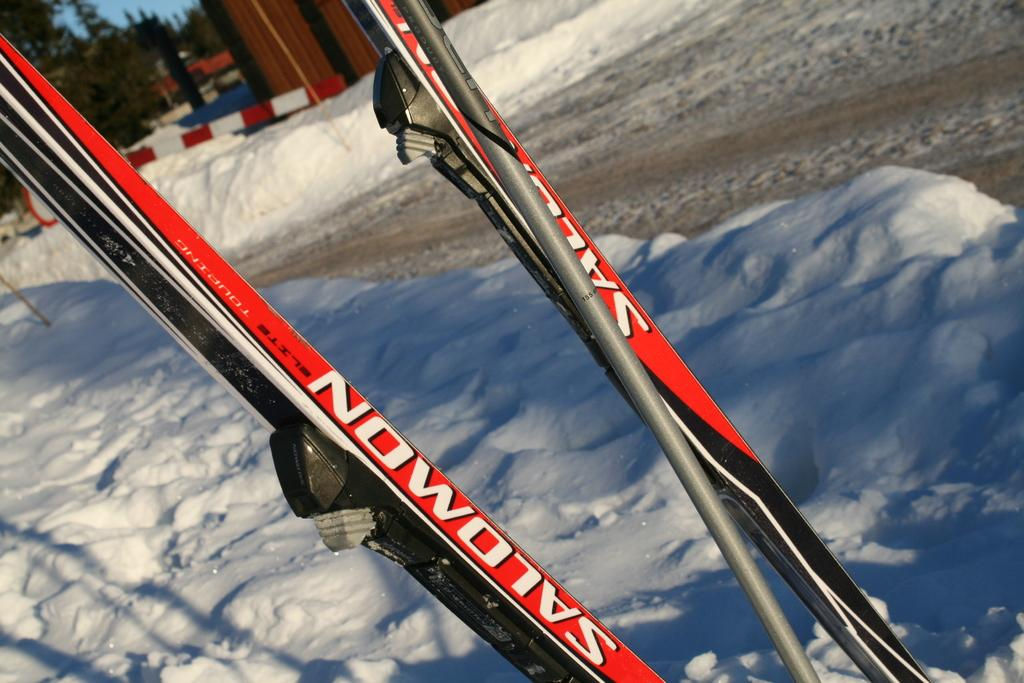What objects are in the foreground of the image? There are sticks in the foreground of the image. What type of weather is depicted in the image? There is snow at the bottom of the image, indicating a snowy scene. What structures can be seen in the background of the image? There are buildings and a pole in the background of the image. What type of vegetation is visible in the background of the image? There are trees in the background of the image. Is there snow present in the background of the image? Yes, there is snow in the background of the image. What type of prose can be seen written on the pole in the image? There is no prose or writing visible on the pole in the image. How many balloons are tied to the trees in the image? There are no balloons present in the image. 